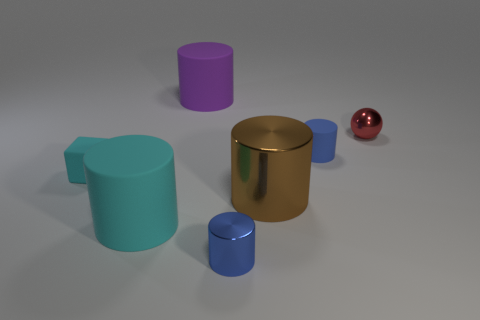Add 3 tiny rubber cylinders. How many objects exist? 10 Subtract all purple cylinders. How many cylinders are left? 4 Subtract all large shiny cylinders. How many cylinders are left? 4 Subtract all spheres. How many objects are left? 6 Subtract 4 cylinders. How many cylinders are left? 1 Subtract all yellow cylinders. Subtract all green blocks. How many cylinders are left? 5 Subtract all blue blocks. How many green spheres are left? 0 Subtract all big brown cylinders. Subtract all cyan things. How many objects are left? 4 Add 2 red things. How many red things are left? 3 Add 4 blue metal cubes. How many blue metal cubes exist? 4 